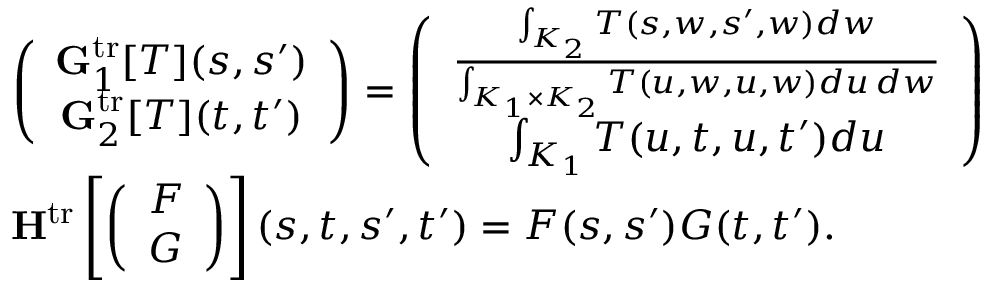Convert formula to latex. <formula><loc_0><loc_0><loc_500><loc_500>\begin{array} { r l } & { \left ( \begin{array} { c } { G _ { 1 } ^ { t r } [ T ] ( s , s ^ { \prime } ) } \\ { G _ { 2 } ^ { t r } [ T ] ( t , t ^ { \prime } ) } \end{array} \right ) = \left ( \begin{array} { c } { \frac { \int _ { K _ { 2 } } T ( s , w , s ^ { \prime } , w ) d w } { \int _ { K _ { 1 } \times K _ { 2 } } T ( u , w , u , w ) d u \, d w } } \\ { \int _ { K _ { 1 } } T ( u , t , u , t ^ { \prime } ) d u } \end{array} \right ) } \\ & { H ^ { t r } \left [ \left ( \begin{array} { c } { F } \\ { G } \end{array} \right ) \right ] ( s , t , s ^ { \prime } , t ^ { \prime } ) = F ( s , s ^ { \prime } ) G ( t , t ^ { \prime } ) . } \end{array}</formula> 